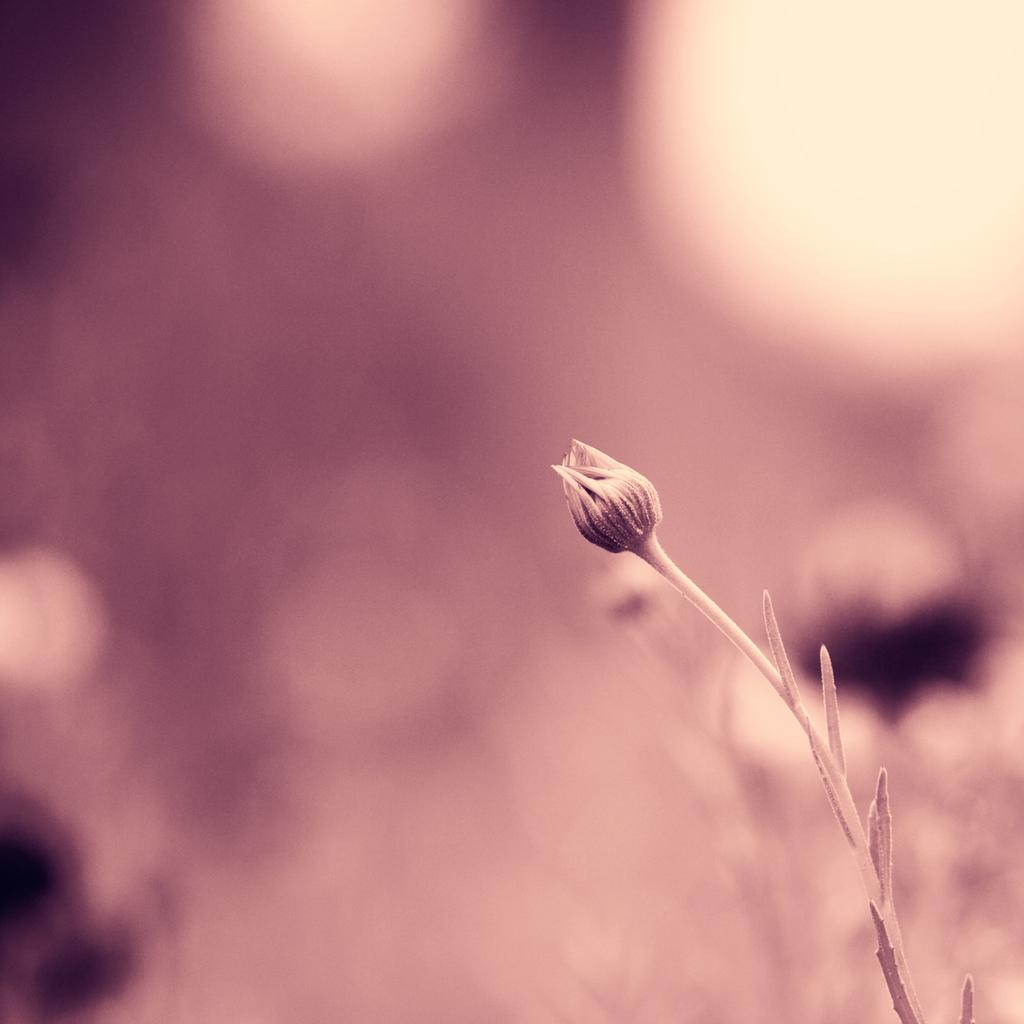What is present in the image that is not a part of the background? There is a bug in the image. What is the color of the bug? The bug is pink in color. How would you describe the background of the image? The background of the image is pink and cream in color. How many horses can be seen in the image? There are no horses present in the image. What is the size of the crow in the image? There is no crow present in the image. 